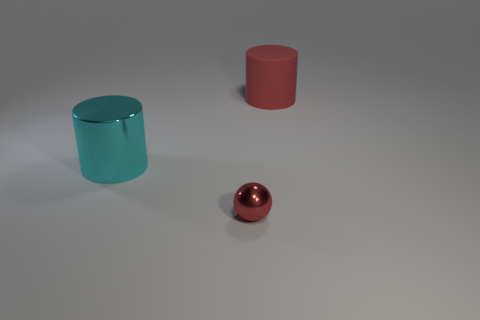Add 3 red cylinders. How many objects exist? 6 Subtract all spheres. How many objects are left? 2 Add 2 small shiny cylinders. How many small shiny cylinders exist? 2 Subtract 0 yellow spheres. How many objects are left? 3 Subtract all big red matte blocks. Subtract all metallic spheres. How many objects are left? 2 Add 3 cyan objects. How many cyan objects are left? 4 